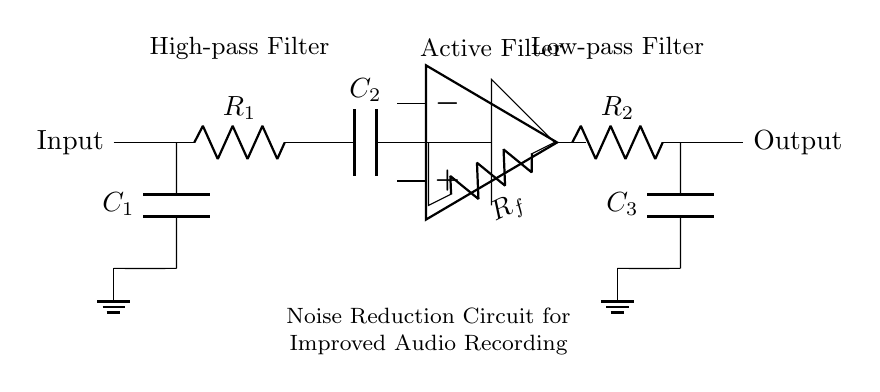What type of filters are used in this circuit? The circuit includes a high-pass filter and a low-pass filter, as indicated in the labels near the components. The high-pass filter is implemented with a resistor and capacitor, while the low-pass filter uses another resistor and capacitor.
Answer: High-pass and low-pass What is the role of the operational amplifier in this circuit? The operational amplifier is used within the active filter section of the circuit to amplify the audio signal and enhance the filtering process, balancing the response of the high and low-pass filters for better noise reduction.
Answer: Signal amplification How many capacitors are present in the circuit? The circuit diagram features three capacitors: C1, C2, and C3, which are all clearly labeled and contribute to the filter functionality.
Answer: Three What is the value of the feedback resistor in the circuit? The feedback resistor, labeled as Rf, is crucial for determining the gain of the op-amp and stabilizing the operation of the active filter. The diagram specifies it as Rf, but does not provide a numerical value for resistance.
Answer: Rf What is the purpose of the ground connections in the circuit? Ground connections are essential for completing the circuits at various points, ensuring stable reference voltages and preventing noise interference, as seen at C1 and C3. Each capacitor has a ground connection to enable proper circuit function.
Answer: Voltage reference What is the input to the circuit labeled as? The input to the circuit is labeled simply as "Input," indicating where the audio signal enters the noise reduction circuit for processing before reaching the output.
Answer: Input What differentiates this circuit as a noise reduction circuit? The combination of high-pass and low-pass filters in conjunction with the operational amplifier allows the circuit to attenuate unwanted noise from the audio recording, enhancing overall audio quality, as indicated by the label "Noise Reduction Circuit for Improved Audio Recording."
Answer: Noise reduction capability 